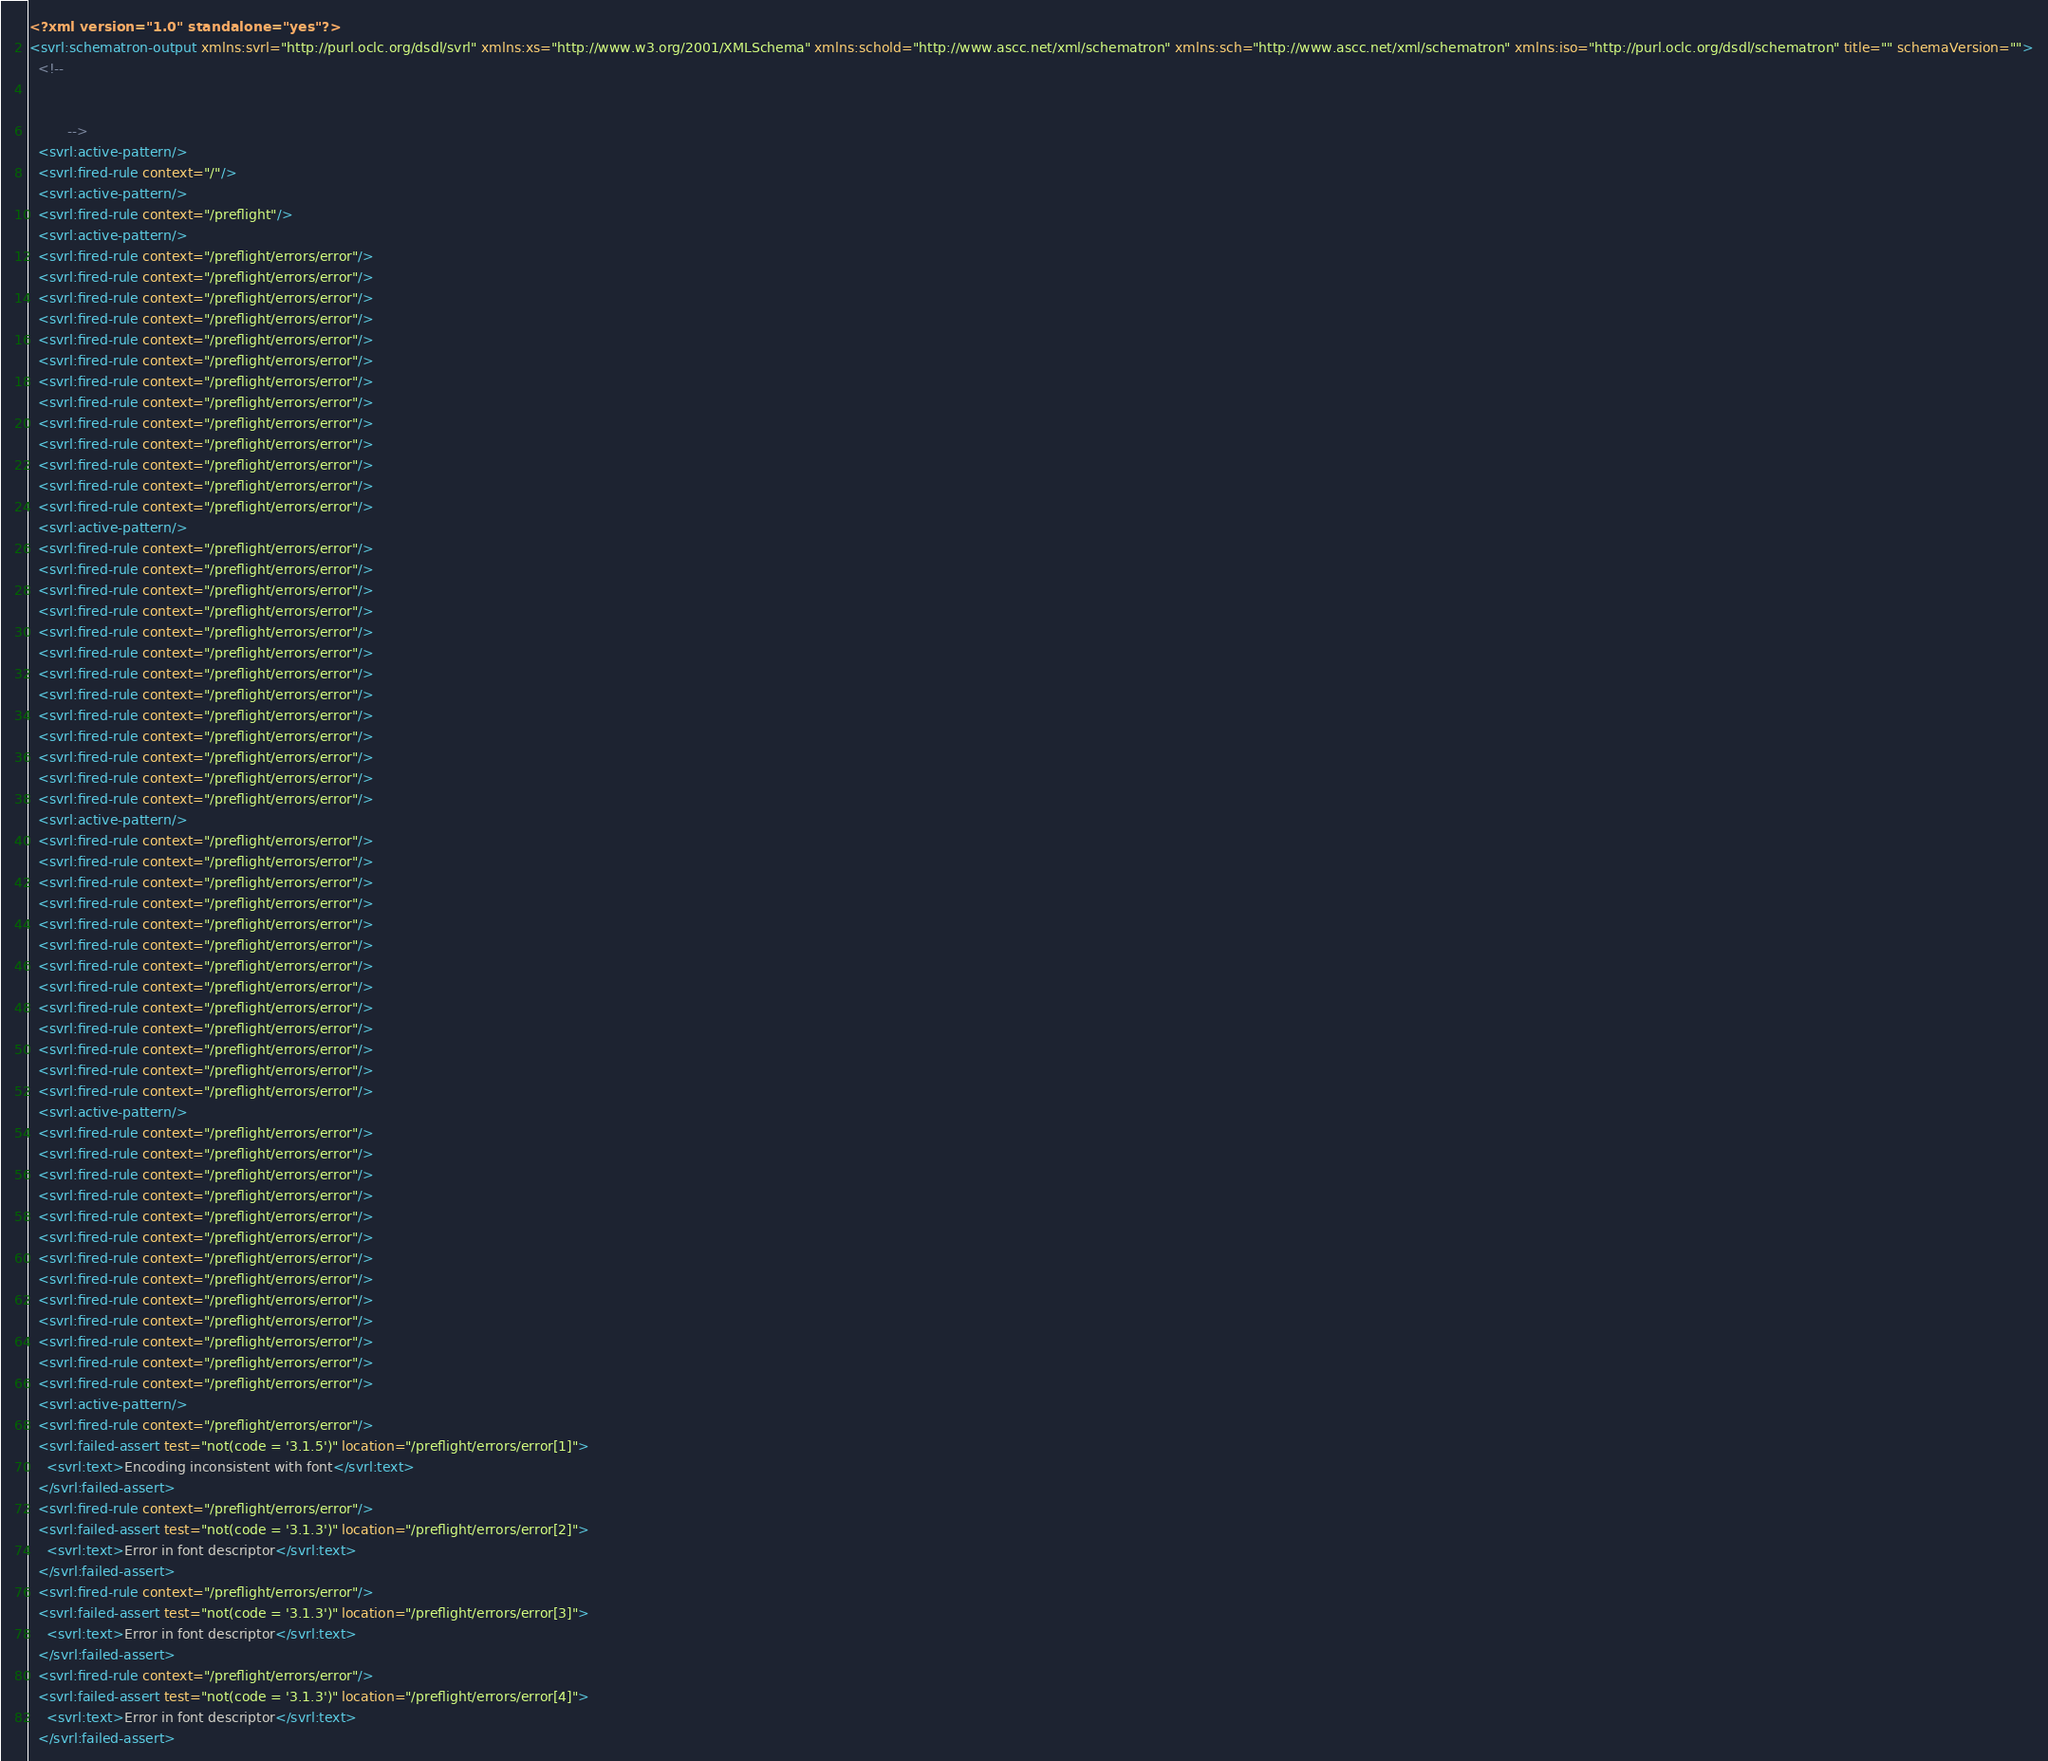<code> <loc_0><loc_0><loc_500><loc_500><_XML_><?xml version="1.0" standalone="yes"?>
<svrl:schematron-output xmlns:svrl="http://purl.oclc.org/dsdl/svrl" xmlns:xs="http://www.w3.org/2001/XMLSchema" xmlns:schold="http://www.ascc.net/xml/schematron" xmlns:sch="http://www.ascc.net/xml/schematron" xmlns:iso="http://purl.oclc.org/dsdl/schematron" title="" schemaVersion="">
  <!--   
		   
		   
		 -->
  <svrl:active-pattern/>
  <svrl:fired-rule context="/"/>
  <svrl:active-pattern/>
  <svrl:fired-rule context="/preflight"/>
  <svrl:active-pattern/>
  <svrl:fired-rule context="/preflight/errors/error"/>
  <svrl:fired-rule context="/preflight/errors/error"/>
  <svrl:fired-rule context="/preflight/errors/error"/>
  <svrl:fired-rule context="/preflight/errors/error"/>
  <svrl:fired-rule context="/preflight/errors/error"/>
  <svrl:fired-rule context="/preflight/errors/error"/>
  <svrl:fired-rule context="/preflight/errors/error"/>
  <svrl:fired-rule context="/preflight/errors/error"/>
  <svrl:fired-rule context="/preflight/errors/error"/>
  <svrl:fired-rule context="/preflight/errors/error"/>
  <svrl:fired-rule context="/preflight/errors/error"/>
  <svrl:fired-rule context="/preflight/errors/error"/>
  <svrl:fired-rule context="/preflight/errors/error"/>
  <svrl:active-pattern/>
  <svrl:fired-rule context="/preflight/errors/error"/>
  <svrl:fired-rule context="/preflight/errors/error"/>
  <svrl:fired-rule context="/preflight/errors/error"/>
  <svrl:fired-rule context="/preflight/errors/error"/>
  <svrl:fired-rule context="/preflight/errors/error"/>
  <svrl:fired-rule context="/preflight/errors/error"/>
  <svrl:fired-rule context="/preflight/errors/error"/>
  <svrl:fired-rule context="/preflight/errors/error"/>
  <svrl:fired-rule context="/preflight/errors/error"/>
  <svrl:fired-rule context="/preflight/errors/error"/>
  <svrl:fired-rule context="/preflight/errors/error"/>
  <svrl:fired-rule context="/preflight/errors/error"/>
  <svrl:fired-rule context="/preflight/errors/error"/>
  <svrl:active-pattern/>
  <svrl:fired-rule context="/preflight/errors/error"/>
  <svrl:fired-rule context="/preflight/errors/error"/>
  <svrl:fired-rule context="/preflight/errors/error"/>
  <svrl:fired-rule context="/preflight/errors/error"/>
  <svrl:fired-rule context="/preflight/errors/error"/>
  <svrl:fired-rule context="/preflight/errors/error"/>
  <svrl:fired-rule context="/preflight/errors/error"/>
  <svrl:fired-rule context="/preflight/errors/error"/>
  <svrl:fired-rule context="/preflight/errors/error"/>
  <svrl:fired-rule context="/preflight/errors/error"/>
  <svrl:fired-rule context="/preflight/errors/error"/>
  <svrl:fired-rule context="/preflight/errors/error"/>
  <svrl:fired-rule context="/preflight/errors/error"/>
  <svrl:active-pattern/>
  <svrl:fired-rule context="/preflight/errors/error"/>
  <svrl:fired-rule context="/preflight/errors/error"/>
  <svrl:fired-rule context="/preflight/errors/error"/>
  <svrl:fired-rule context="/preflight/errors/error"/>
  <svrl:fired-rule context="/preflight/errors/error"/>
  <svrl:fired-rule context="/preflight/errors/error"/>
  <svrl:fired-rule context="/preflight/errors/error"/>
  <svrl:fired-rule context="/preflight/errors/error"/>
  <svrl:fired-rule context="/preflight/errors/error"/>
  <svrl:fired-rule context="/preflight/errors/error"/>
  <svrl:fired-rule context="/preflight/errors/error"/>
  <svrl:fired-rule context="/preflight/errors/error"/>
  <svrl:fired-rule context="/preflight/errors/error"/>
  <svrl:active-pattern/>
  <svrl:fired-rule context="/preflight/errors/error"/>
  <svrl:failed-assert test="not(code = '3.1.5')" location="/preflight/errors/error[1]">
    <svrl:text>Encoding inconsistent with font</svrl:text>
  </svrl:failed-assert>
  <svrl:fired-rule context="/preflight/errors/error"/>
  <svrl:failed-assert test="not(code = '3.1.3')" location="/preflight/errors/error[2]">
    <svrl:text>Error in font descriptor</svrl:text>
  </svrl:failed-assert>
  <svrl:fired-rule context="/preflight/errors/error"/>
  <svrl:failed-assert test="not(code = '3.1.3')" location="/preflight/errors/error[3]">
    <svrl:text>Error in font descriptor</svrl:text>
  </svrl:failed-assert>
  <svrl:fired-rule context="/preflight/errors/error"/>
  <svrl:failed-assert test="not(code = '3.1.3')" location="/preflight/errors/error[4]">
    <svrl:text>Error in font descriptor</svrl:text>
  </svrl:failed-assert></code> 